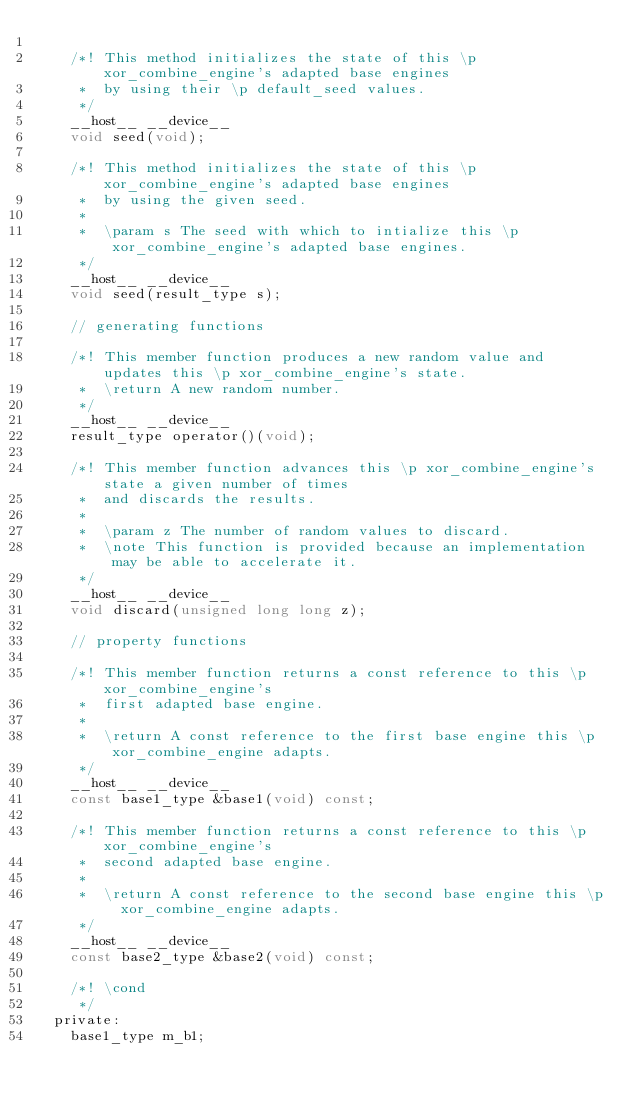Convert code to text. <code><loc_0><loc_0><loc_500><loc_500><_C_>
    /*! This method initializes the state of this \p xor_combine_engine's adapted base engines
     *  by using their \p default_seed values.
     */
    __host__ __device__
    void seed(void);

    /*! This method initializes the state of this \p xor_combine_engine's adapted base engines
     *  by using the given seed.
     *
     *  \param s The seed with which to intialize this \p xor_combine_engine's adapted base engines.
     */
    __host__ __device__
    void seed(result_type s);

    // generating functions

    /*! This member function produces a new random value and updates this \p xor_combine_engine's state.
     *  \return A new random number.
     */
    __host__ __device__
    result_type operator()(void);

    /*! This member function advances this \p xor_combine_engine's state a given number of times
     *  and discards the results.
     *
     *  \param z The number of random values to discard.
     *  \note This function is provided because an implementation may be able to accelerate it.
     */
    __host__ __device__
    void discard(unsigned long long z);

    // property functions

    /*! This member function returns a const reference to this \p xor_combine_engine's
     *  first adapted base engine.
     *
     *  \return A const reference to the first base engine this \p xor_combine_engine adapts.
     */
    __host__ __device__
    const base1_type &base1(void) const;

    /*! This member function returns a const reference to this \p xor_combine_engine's
     *  second adapted base engine.
     *
     *  \return A const reference to the second base engine this \p xor_combine_engine adapts.
     */
    __host__ __device__
    const base2_type &base2(void) const;

    /*! \cond
     */
  private:
    base1_type m_b1;</code> 